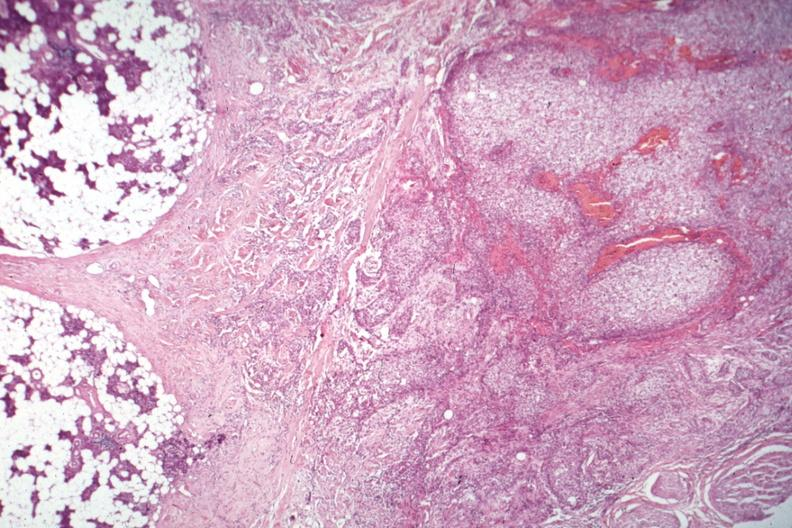s this typical lesion present?
Answer the question using a single word or phrase. No 